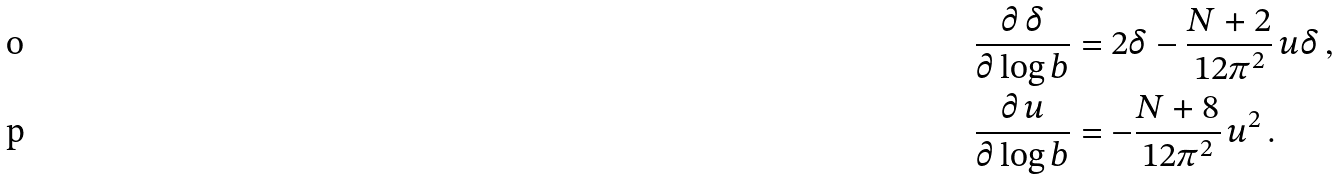<formula> <loc_0><loc_0><loc_500><loc_500>\frac { \partial \, \delta } { \partial \log b } & = 2 \delta - \frac { N + 2 } { 1 2 \pi ^ { 2 } } \, u \delta \, , \\ \frac { \partial \, u } { \partial \log b } & = - \frac { N + 8 } { 1 2 \pi ^ { 2 } } \, u ^ { 2 } \, .</formula> 